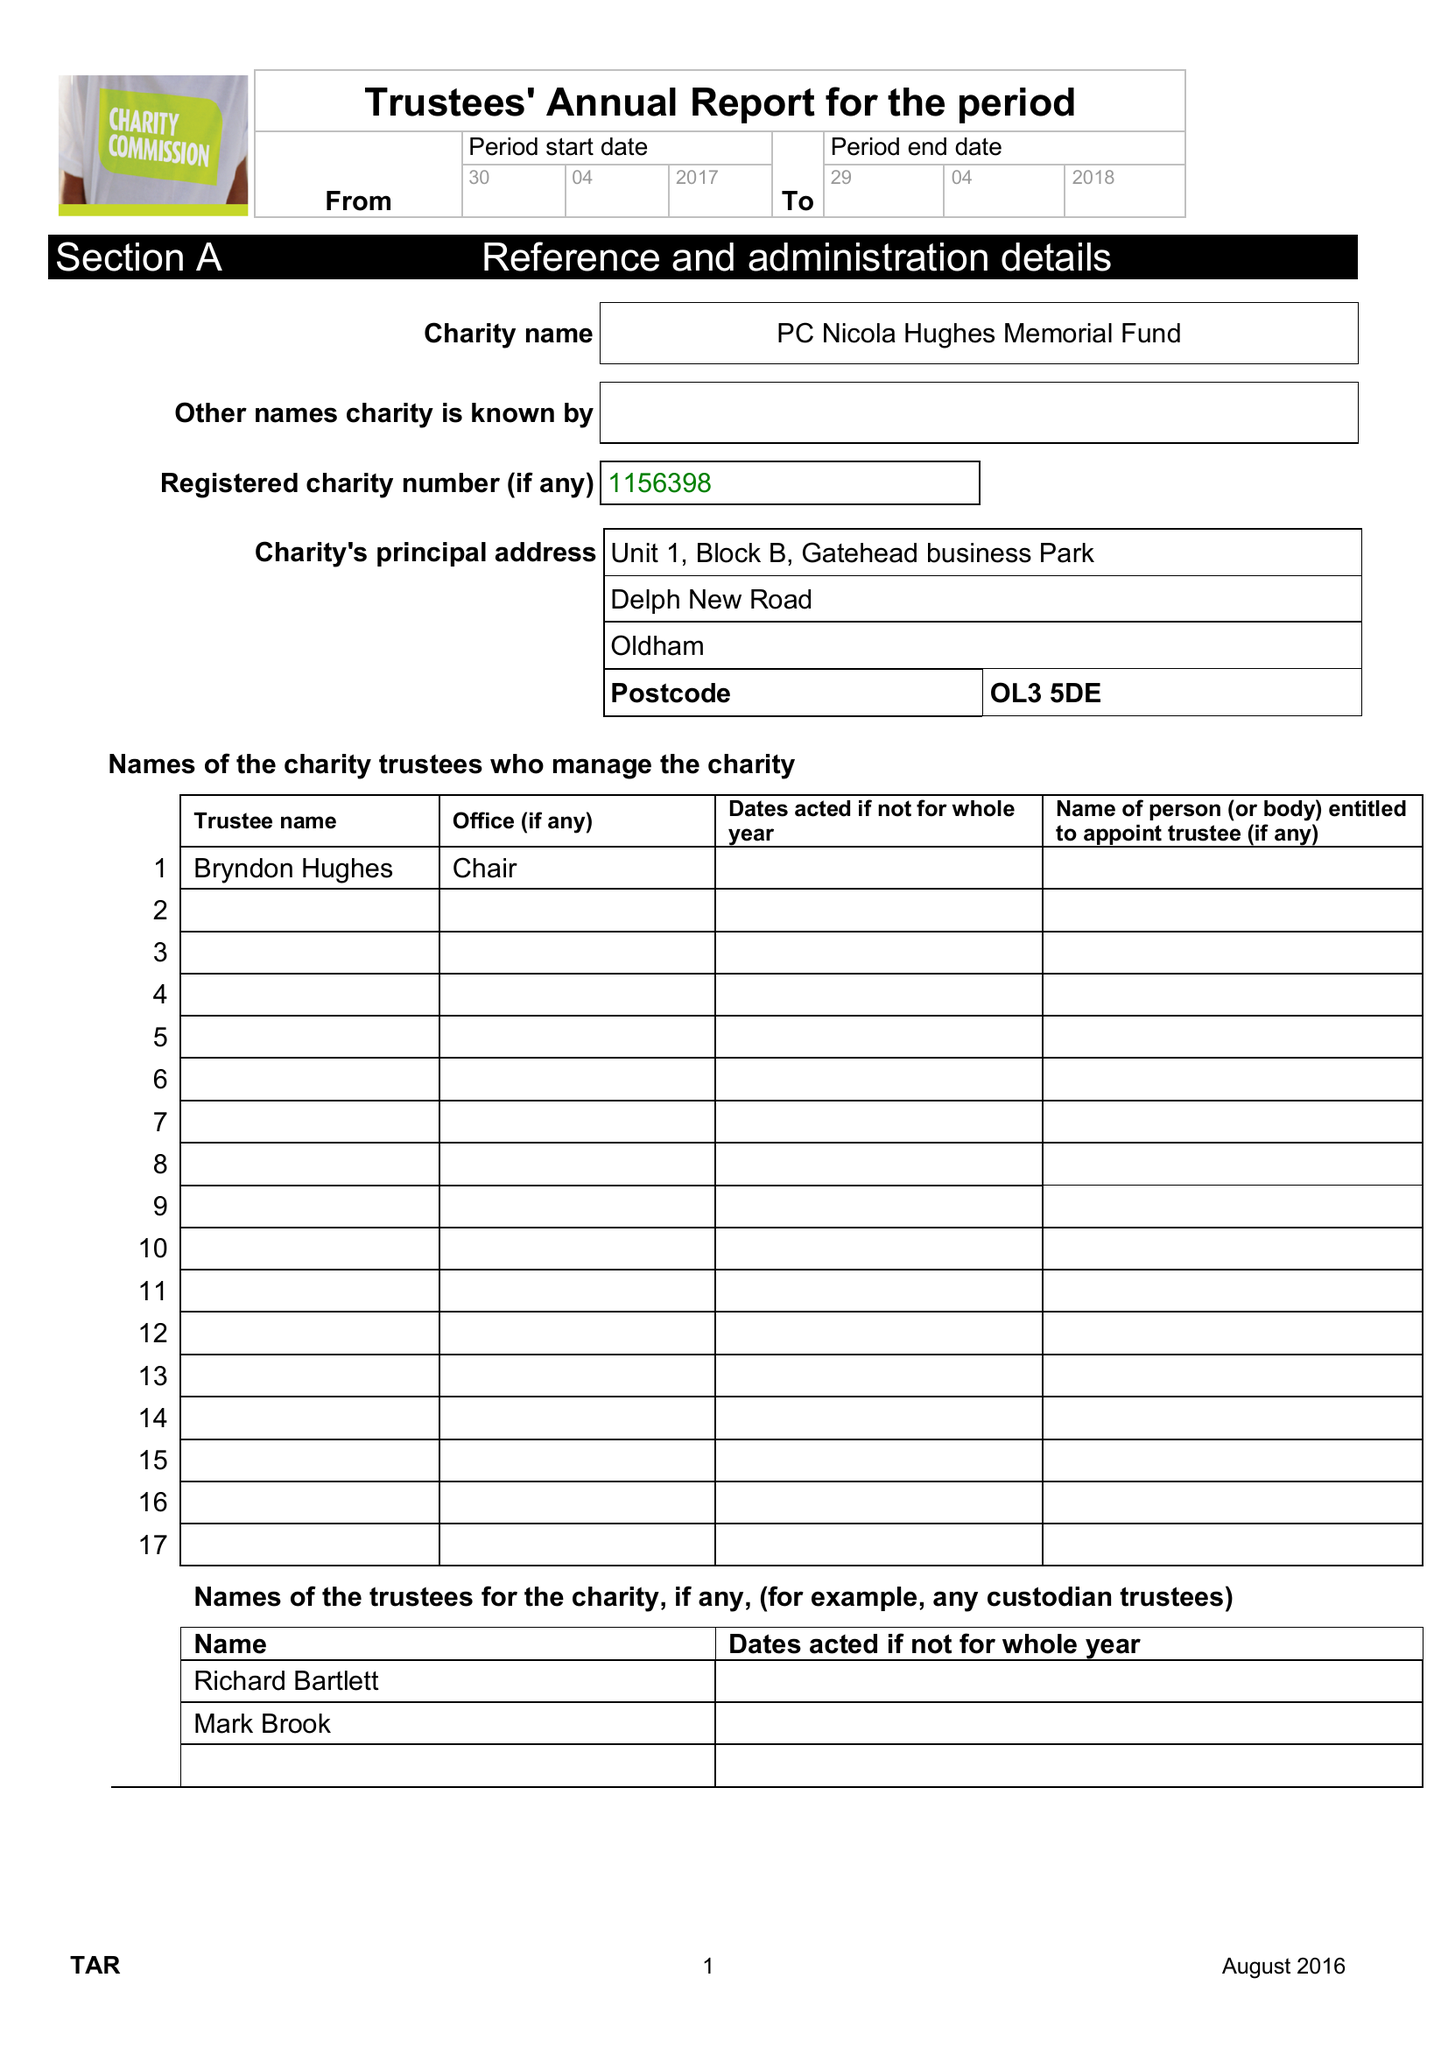What is the value for the spending_annually_in_british_pounds?
Answer the question using a single word or phrase. 73311.00 